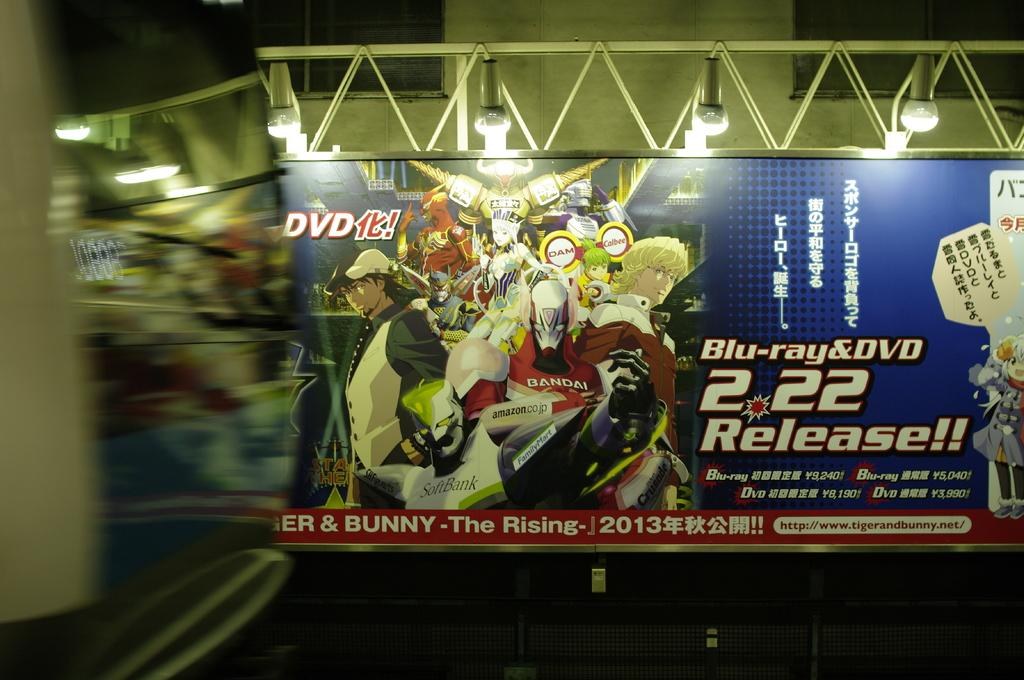Provide a one-sentence caption for the provided image. Blu ray and dvd release of the rising in 2013. 